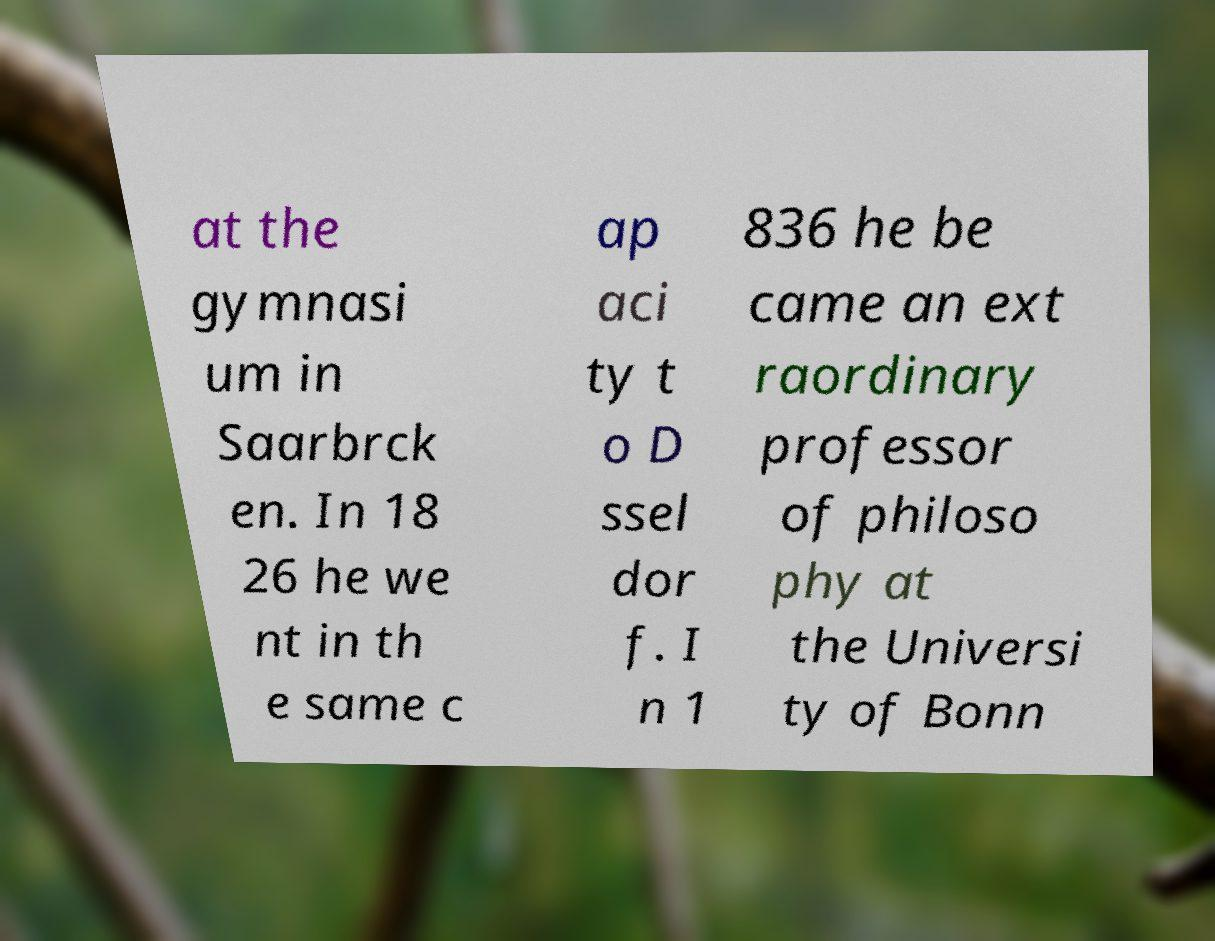Can you read and provide the text displayed in the image?This photo seems to have some interesting text. Can you extract and type it out for me? at the gymnasi um in Saarbrck en. In 18 26 he we nt in th e same c ap aci ty t o D ssel dor f. I n 1 836 he be came an ext raordinary professor of philoso phy at the Universi ty of Bonn 